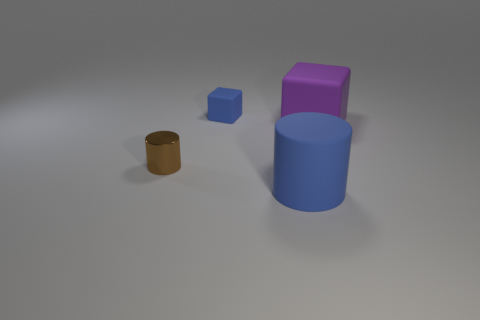What number of cylinders are the same color as the small matte block? The small matte block appears to be blue. Considering the colors of the shapes in the image, there is one cylindrical object of the same color as the small matte block. 